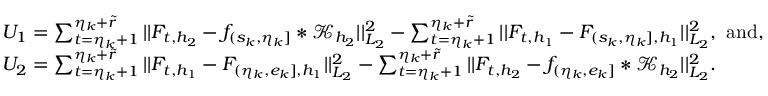<formula> <loc_0><loc_0><loc_500><loc_500>\begin{array} { r l } & { U _ { 1 } = \sum _ { t = \eta _ { k } + 1 } ^ { \eta _ { k } + \widetilde { r } } | | F _ { t , { h _ { 2 } } } - f _ { ( s _ { k } , \eta _ { k } ] } \ast \mathcal { K } _ { { h _ { 2 } } } | | _ { L _ { 2 } } ^ { 2 } - \sum _ { t = \eta _ { k } + 1 } ^ { \eta _ { k } + \widetilde { r } } | | F _ { t , { h _ { 1 } } } - F _ { ( s _ { k } , \eta _ { k } ] , { h _ { 1 } } } | | _ { L _ { 2 } } ^ { 2 } , \ a n d , } \\ & { U _ { 2 } = \sum _ { t = \eta _ { k } + 1 } ^ { \eta _ { k } + \widetilde { r } } | | F _ { t , { h _ { 1 } } } - F _ { ( \eta _ { k } , e _ { k } ] , { h _ { 1 } } } | | _ { L _ { 2 } } ^ { 2 } - \sum _ { t = \eta _ { k } + 1 } ^ { \eta _ { k } + \widetilde { r } } | | F _ { t , { h _ { 2 } } } - f _ { ( \eta _ { k } , e _ { k } ] } \ast \mathcal { K } _ { h _ { 2 } } | | _ { L _ { 2 } } ^ { 2 } . } \end{array}</formula> 